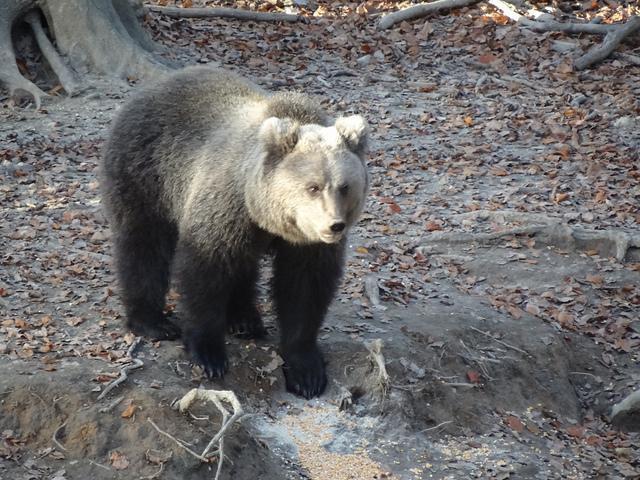How many bears are there?
Give a very brief answer. 1. How many zebras are facing right in the picture?
Give a very brief answer. 0. 